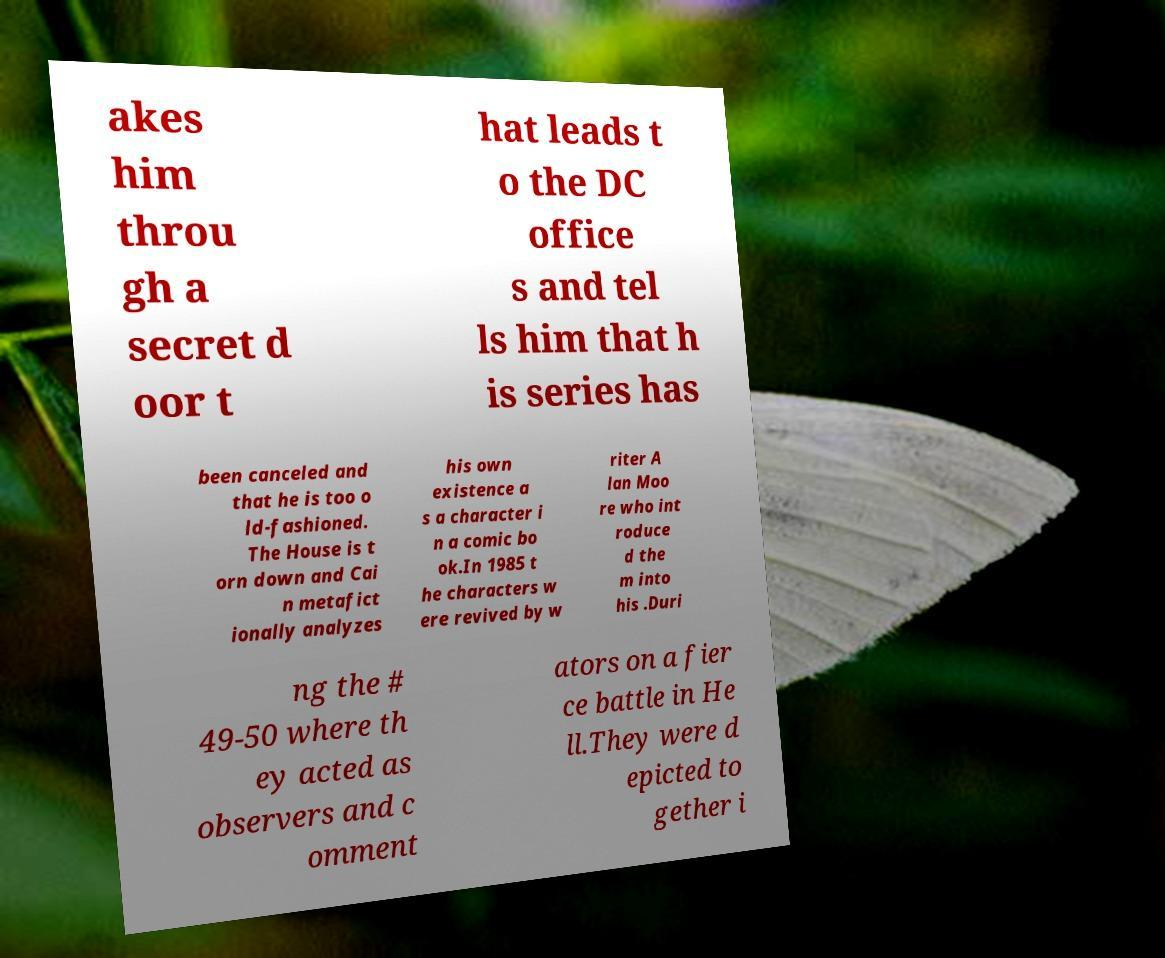Please identify and transcribe the text found in this image. akes him throu gh a secret d oor t hat leads t o the DC office s and tel ls him that h is series has been canceled and that he is too o ld-fashioned. The House is t orn down and Cai n metafict ionally analyzes his own existence a s a character i n a comic bo ok.In 1985 t he characters w ere revived by w riter A lan Moo re who int roduce d the m into his .Duri ng the # 49-50 where th ey acted as observers and c omment ators on a fier ce battle in He ll.They were d epicted to gether i 